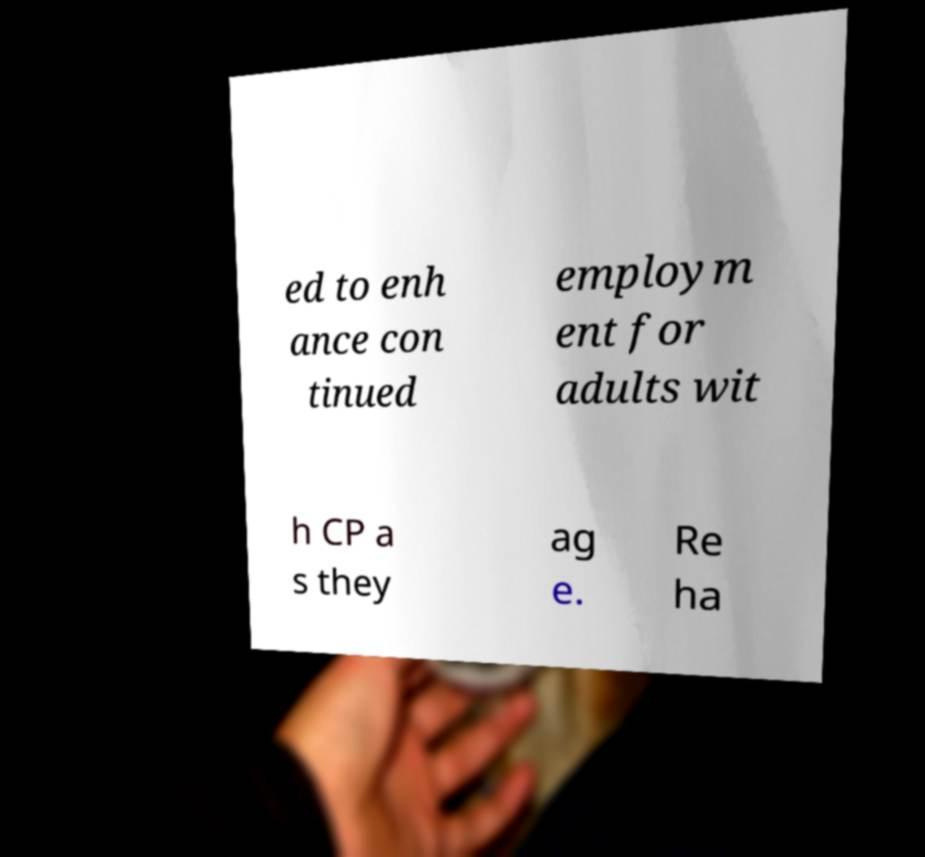Please identify and transcribe the text found in this image. ed to enh ance con tinued employm ent for adults wit h CP a s they ag e. Re ha 